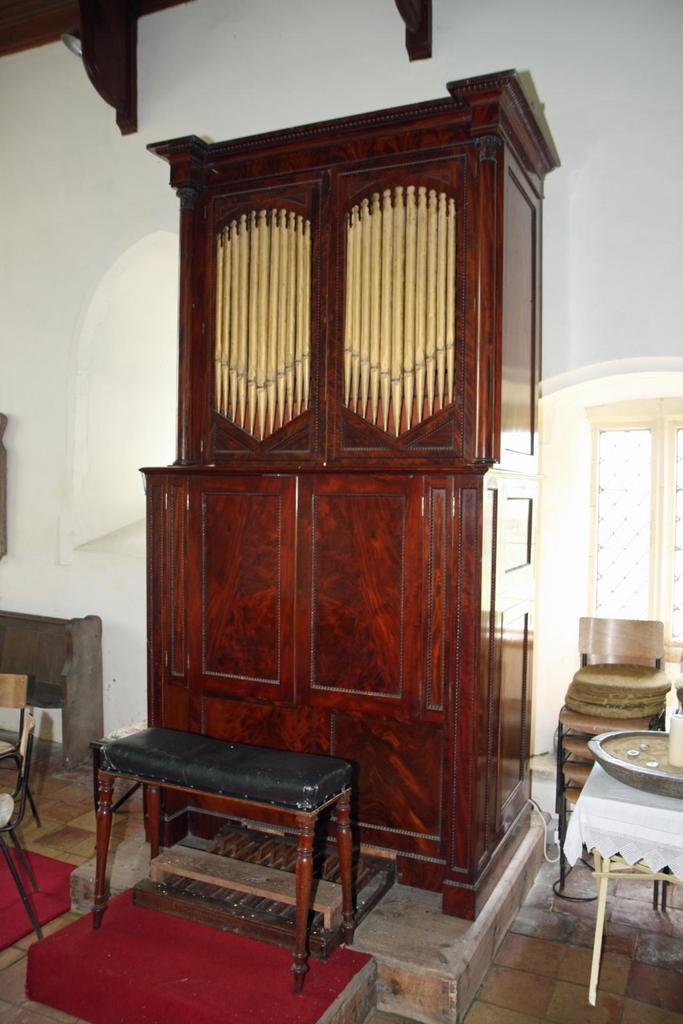What type of furniture can be seen in the image? There are tables in the image. What is located at the back of the image? There is a cabinet at the back of the image. Where is the window in the image? There is a window at the left side of the image. What color is the wall at the back of the image? There is a white wall at the back of the image. What role does the actor play in the image? There is no actor present in the image. What type of branch can be seen growing from the table in the image? There are no branches present in the image, and the tables do not have any growths. 